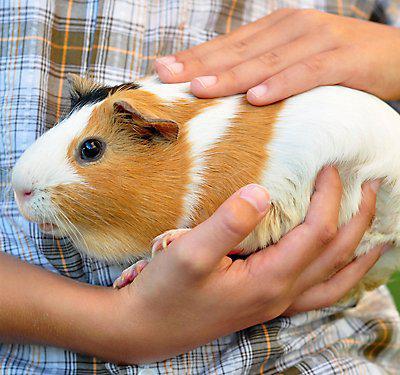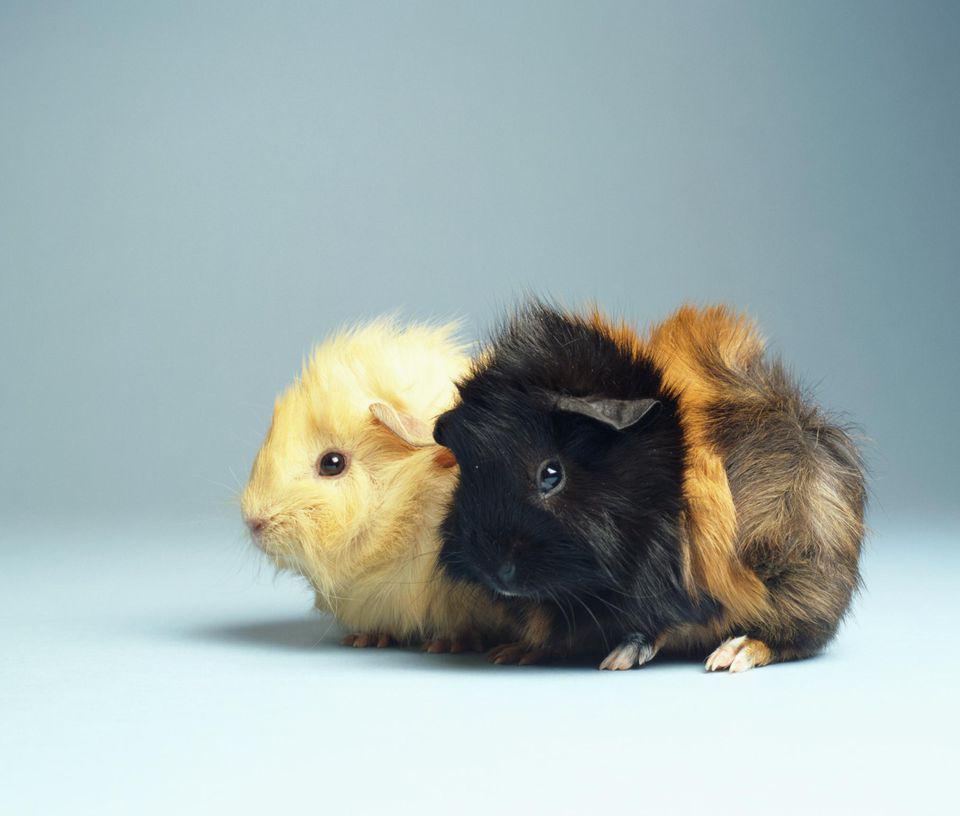The first image is the image on the left, the second image is the image on the right. For the images displayed, is the sentence "A guinea pig with a white snout is facing left." factually correct? Answer yes or no. Yes. 